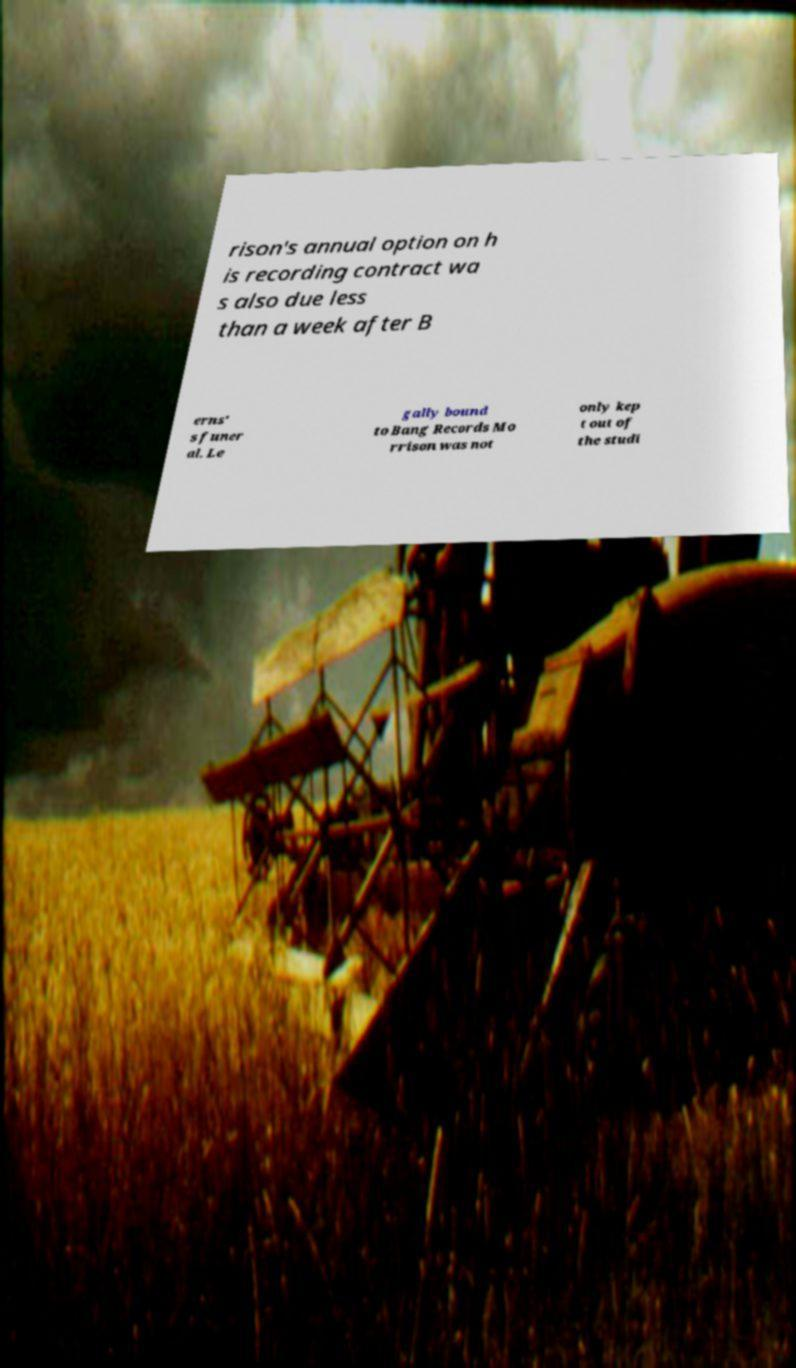Please read and relay the text visible in this image. What does it say? rison's annual option on h is recording contract wa s also due less than a week after B erns' s funer al. Le gally bound to Bang Records Mo rrison was not only kep t out of the studi 